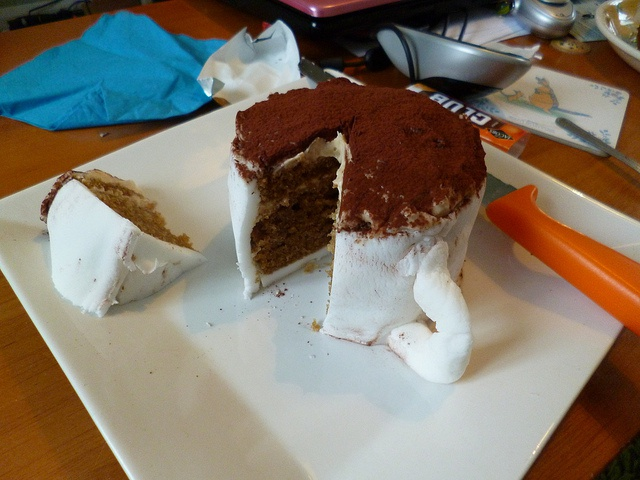Describe the objects in this image and their specific colors. I can see cake in black, maroon, lightgray, and darkgray tones, cake in black, lightgray, darkgray, gray, and maroon tones, knife in black, red, and maroon tones, mouse in black and gray tones, and fork in black, gray, and maroon tones in this image. 